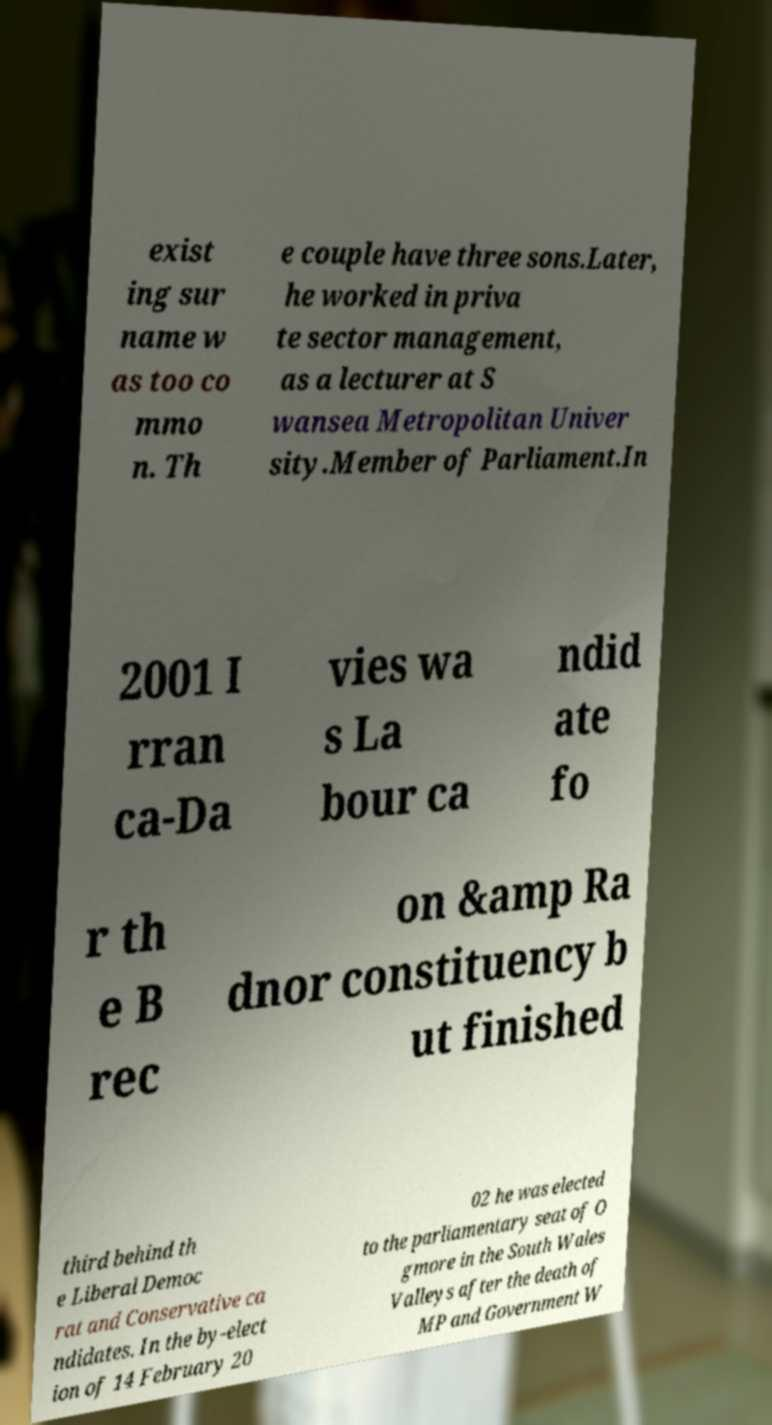Could you extract and type out the text from this image? exist ing sur name w as too co mmo n. Th e couple have three sons.Later, he worked in priva te sector management, as a lecturer at S wansea Metropolitan Univer sity.Member of Parliament.In 2001 I rran ca-Da vies wa s La bour ca ndid ate fo r th e B rec on &amp Ra dnor constituency b ut finished third behind th e Liberal Democ rat and Conservative ca ndidates. In the by-elect ion of 14 February 20 02 he was elected to the parliamentary seat of O gmore in the South Wales Valleys after the death of MP and Government W 